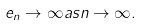<formula> <loc_0><loc_0><loc_500><loc_500>e _ { n } \rightarrow \infty a s n \rightarrow \infty .</formula> 